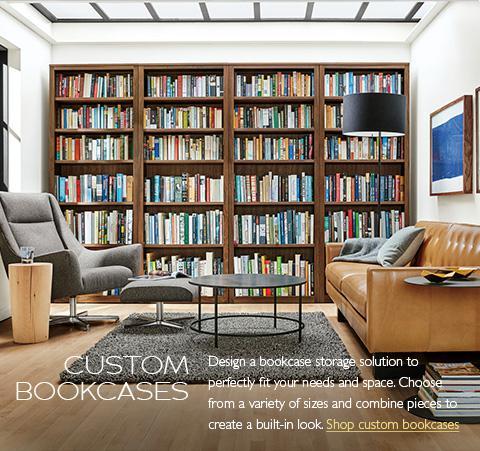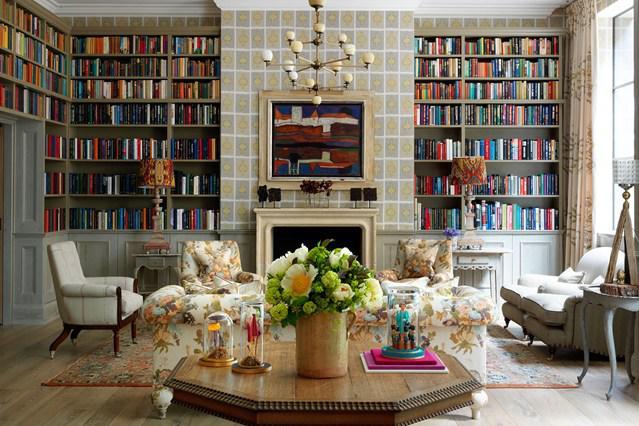The first image is the image on the left, the second image is the image on the right. For the images shown, is this caption "A round coffee table is by a chair with a footstool in front of a wall-filling bookcase." true? Answer yes or no. Yes. The first image is the image on the left, the second image is the image on the right. Examine the images to the left and right. Is the description "The center table in one of the images holds a container with blooming flowers." accurate? Answer yes or no. Yes. 